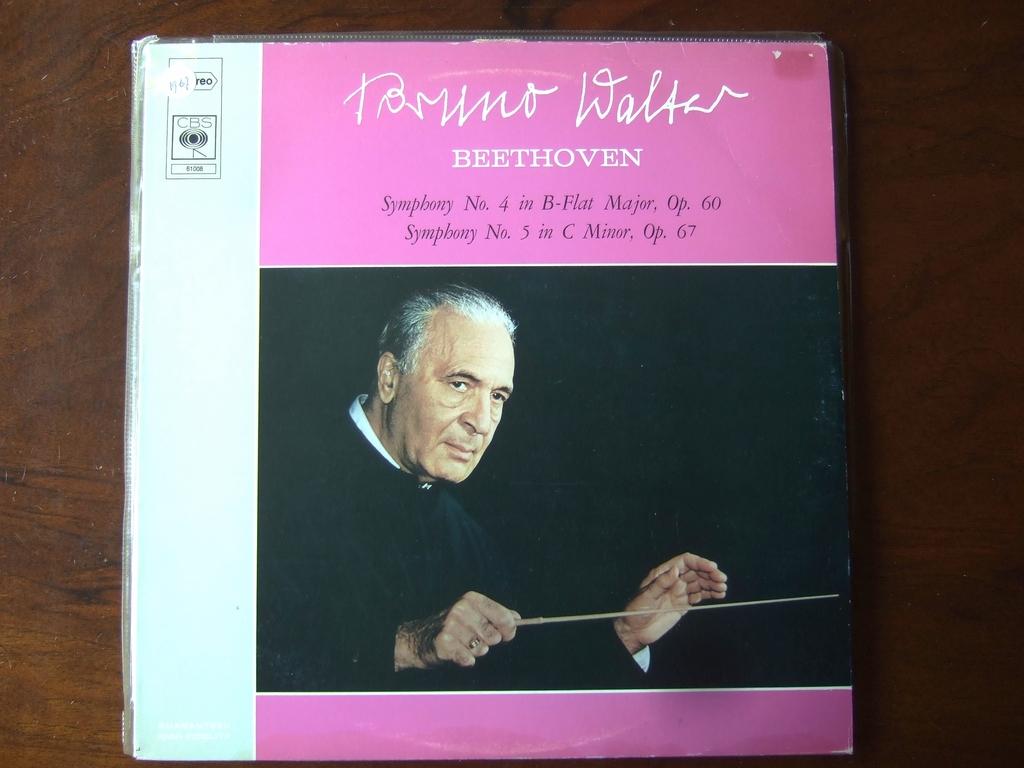What symphony number is in b-flat major?
Provide a short and direct response. 4. Who's works are being performed on this record?
Keep it short and to the point. Beethoven. 